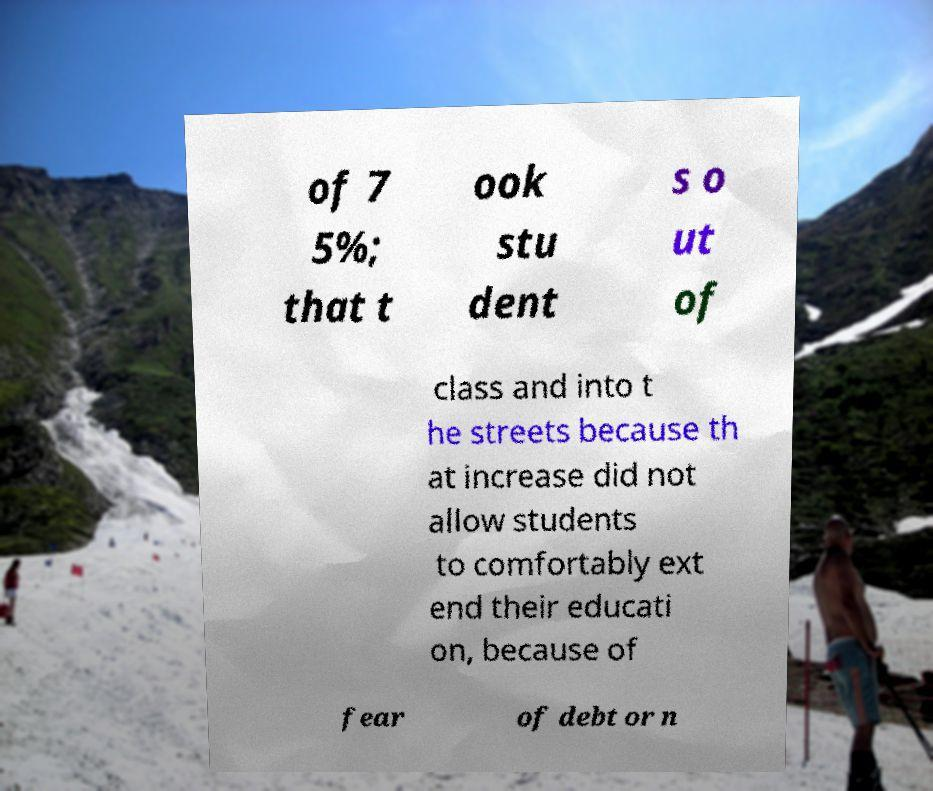Please identify and transcribe the text found in this image. of 7 5%; that t ook stu dent s o ut of class and into t he streets because th at increase did not allow students to comfortably ext end their educati on, because of fear of debt or n 